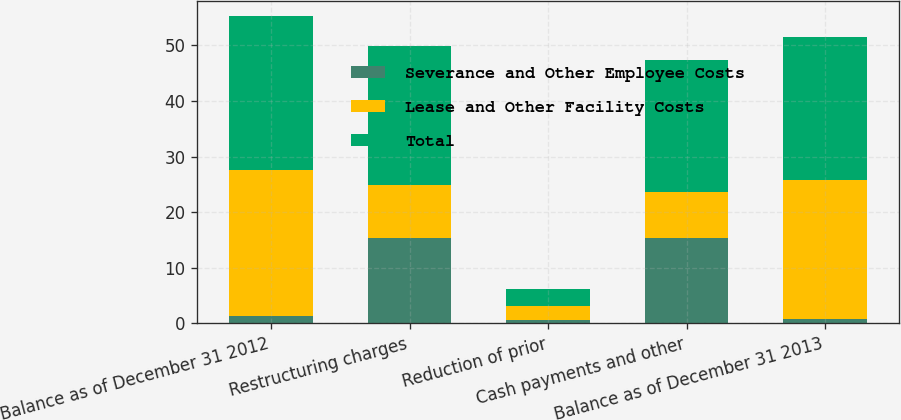<chart> <loc_0><loc_0><loc_500><loc_500><stacked_bar_chart><ecel><fcel>Balance as of December 31 2012<fcel>Restructuring charges<fcel>Reduction of prior<fcel>Cash payments and other<fcel>Balance as of December 31 2013<nl><fcel>Severance and Other Employee Costs<fcel>1.4<fcel>15.4<fcel>0.6<fcel>15.4<fcel>0.8<nl><fcel>Lease and Other Facility Costs<fcel>26.2<fcel>9.5<fcel>2.5<fcel>8.3<fcel>24.9<nl><fcel>Total<fcel>27.6<fcel>24.9<fcel>3.1<fcel>23.7<fcel>25.7<nl></chart> 